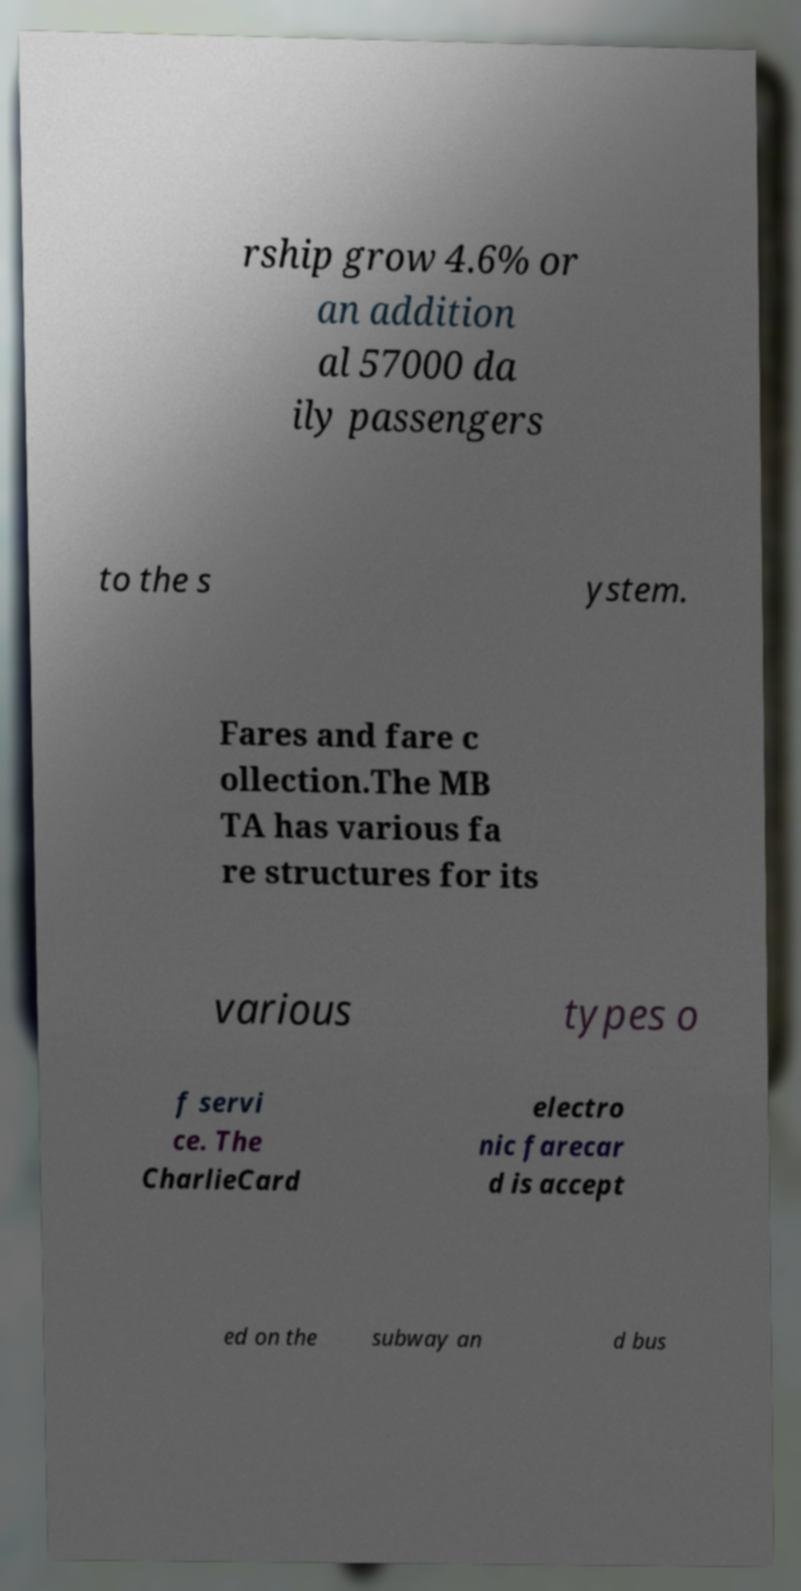I need the written content from this picture converted into text. Can you do that? rship grow 4.6% or an addition al 57000 da ily passengers to the s ystem. Fares and fare c ollection.The MB TA has various fa re structures for its various types o f servi ce. The CharlieCard electro nic farecar d is accept ed on the subway an d bus 